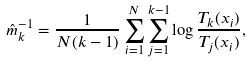<formula> <loc_0><loc_0><loc_500><loc_500>\hat { m } _ { k } ^ { - 1 } = \frac { 1 } { N ( k - 1 ) } \sum _ { i = 1 } ^ { N } \sum _ { j = 1 } ^ { k - 1 } \log \frac { T _ { k } ( x _ { i } ) } { T _ { j } ( x _ { i } ) } ,</formula> 